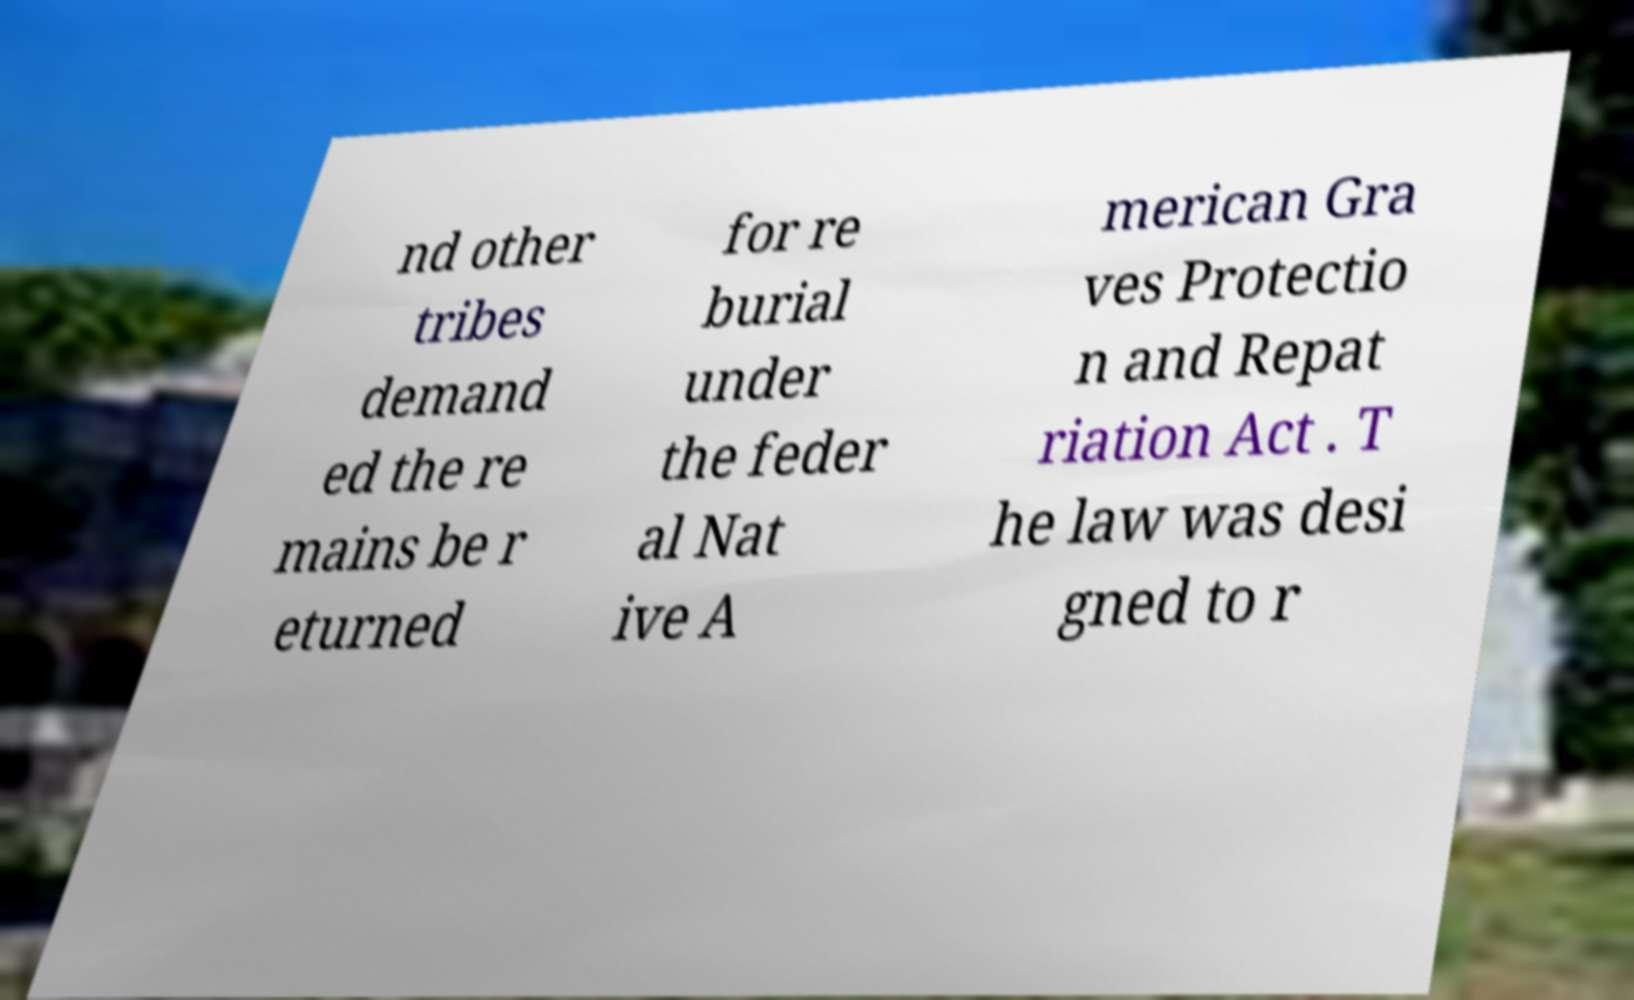Can you read and provide the text displayed in the image?This photo seems to have some interesting text. Can you extract and type it out for me? nd other tribes demand ed the re mains be r eturned for re burial under the feder al Nat ive A merican Gra ves Protectio n and Repat riation Act . T he law was desi gned to r 